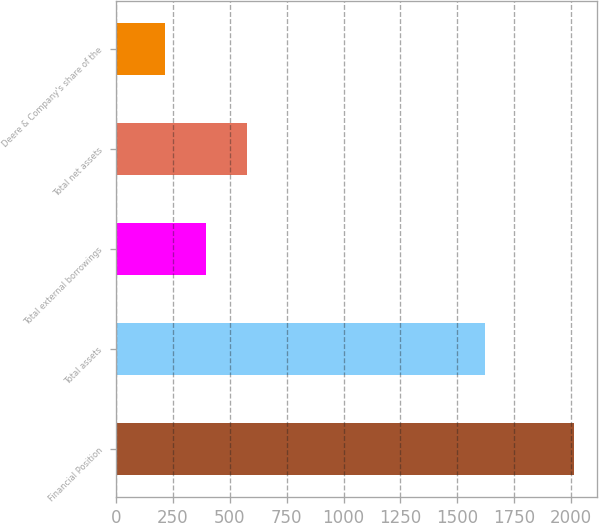Convert chart to OTSL. <chart><loc_0><loc_0><loc_500><loc_500><bar_chart><fcel>Financial Position<fcel>Total assets<fcel>Total external borrowings<fcel>Total net assets<fcel>Deere & Company's share of the<nl><fcel>2012<fcel>1621<fcel>394.7<fcel>574.4<fcel>215<nl></chart> 